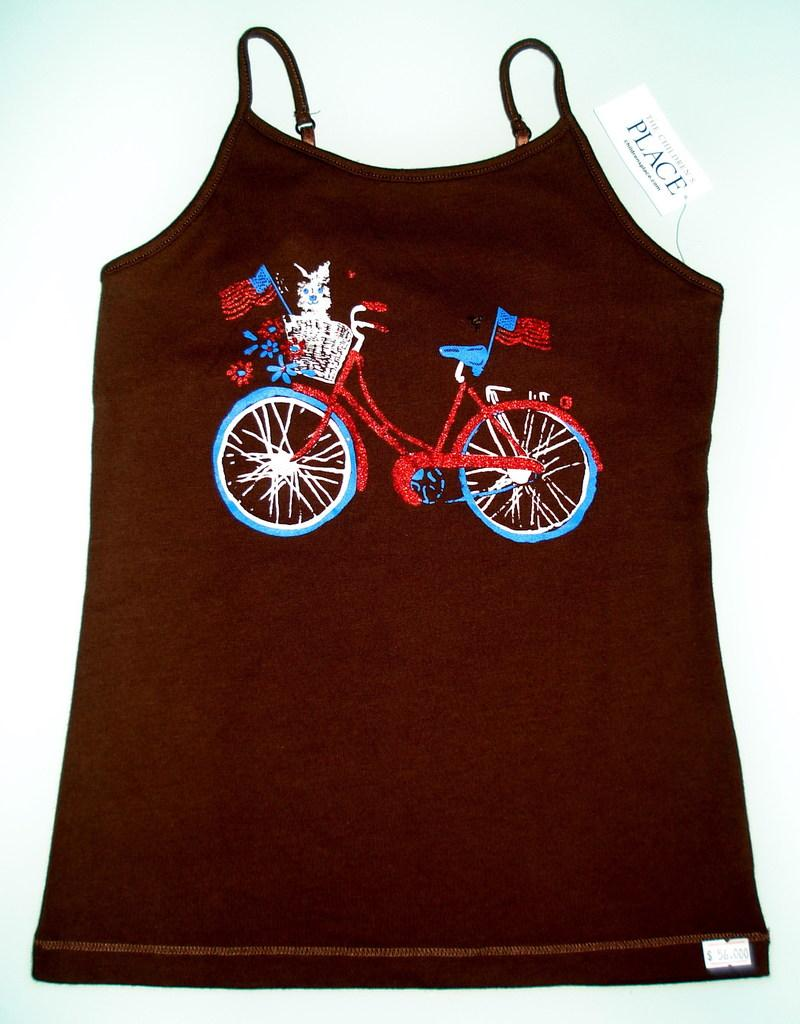What type of clothing item is visible in the image? There is a person's top in the image. What design element can be seen on the top? The top has embroidery work on it. Is there any additional information about the top? Yes, there is a tag on the top. How many trees are growing out of the hole in the top? There are no trees or holes present in the image; it features a person's top with embroidery work and a tag. What type of basin is visible in the image? There is no basin present in the image. 